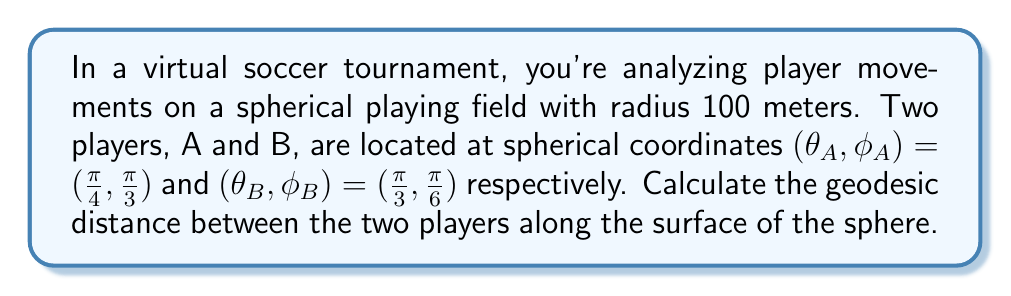Help me with this question. To solve this problem, we'll use the formula for geodesic distance on a sphere, also known as the great-circle distance. The steps are as follows:

1) The formula for geodesic distance $d$ on a sphere of radius $R$ is:

   $$d = R \cdot \arccos(\sin\phi_A \sin\phi_B + \cos\phi_A \cos\phi_B \cos(\theta_B - \theta_A))$$

2) We're given:
   - $R = 100$ meters
   - $(\theta_A, \phi_A) = (\frac{\pi}{4}, \frac{\pi}{3})$
   - $(\theta_B, \phi_B) = (\frac{\pi}{3}, \frac{\pi}{6})$

3) Let's substitute these values into the formula:

   $$d = 100 \cdot \arccos(\sin(\frac{\pi}{3}) \sin(\frac{\pi}{6}) + \cos(\frac{\pi}{3}) \cos(\frac{\pi}{6}) \cos(\frac{\pi}{3} - \frac{\pi}{4}))$$

4) Simplify the trigonometric functions:
   - $\sin(\frac{\pi}{3}) = \frac{\sqrt{3}}{2}$
   - $\sin(\frac{\pi}{6}) = \frac{1}{2}$
   - $\cos(\frac{\pi}{3}) = \frac{1}{2}$
   - $\cos(\frac{\pi}{6}) = \frac{\sqrt{3}}{2}$
   - $\cos(\frac{\pi}{3} - \frac{\pi}{4}) = \cos(\frac{\pi}{12}) = \frac{\sqrt{6}+\sqrt{2}}{4}$

5) Substituting these values:

   $$d = 100 \cdot \arccos((\frac{\sqrt{3}}{2} \cdot \frac{1}{2}) + (\frac{1}{2} \cdot \frac{\sqrt{3}}{2} \cdot \frac{\sqrt{6}+\sqrt{2}}{4}))$$

6) Simplify:

   $$d = 100 \cdot \arccos(\frac{\sqrt{3}}{4} + \frac{\sqrt{6}+\sqrt{2}}{8})$$

7) Using a calculator or computer to evaluate this expression:

   $$d \approx 100 \cdot 0.7154 = 71.54$$

Therefore, the geodesic distance between the two players is approximately 71.54 meters.
Answer: 71.54 meters 